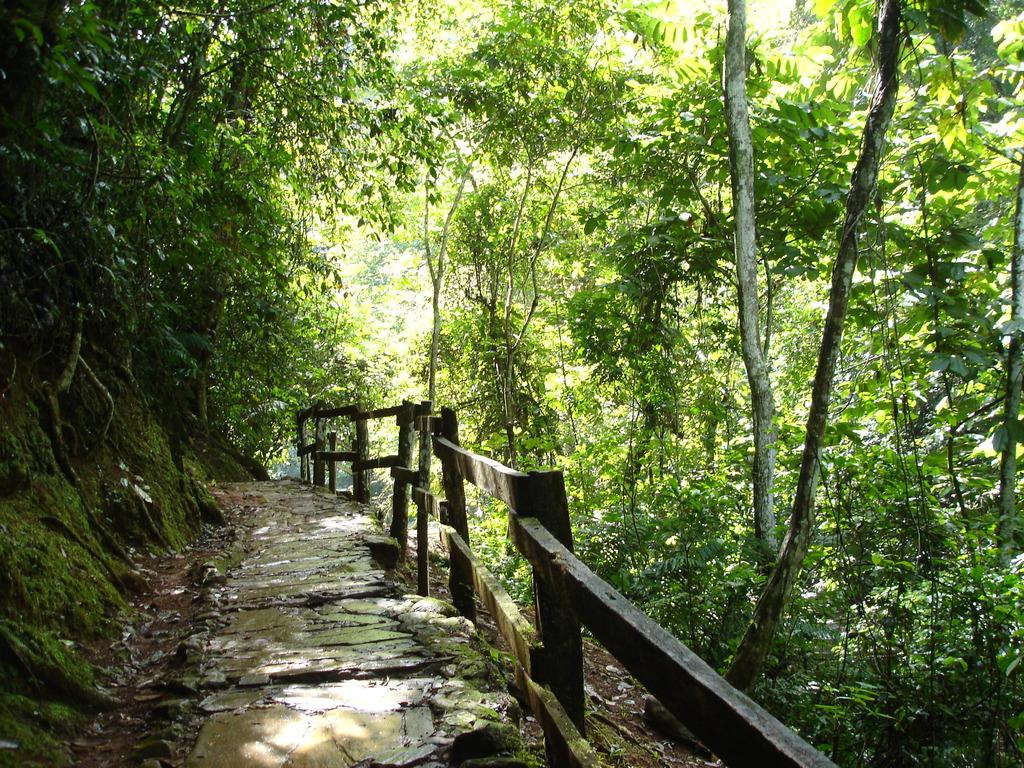What can be seen in the image that people might walk on? There is a path in the image that people might walk on. What feature is present in the image that might provide support or safety? There is a railing in the image that might provide support or safety. What type of natural environment is visible in the background of the image? There are many trees in the background of the image, indicating a forest or wooded area. Can you see a rifle hanging on the railing in the image? No, there is no rifle present in the image. Is your grandmother visible in the image? No, there is no person, including a grandmother, present in the image. 